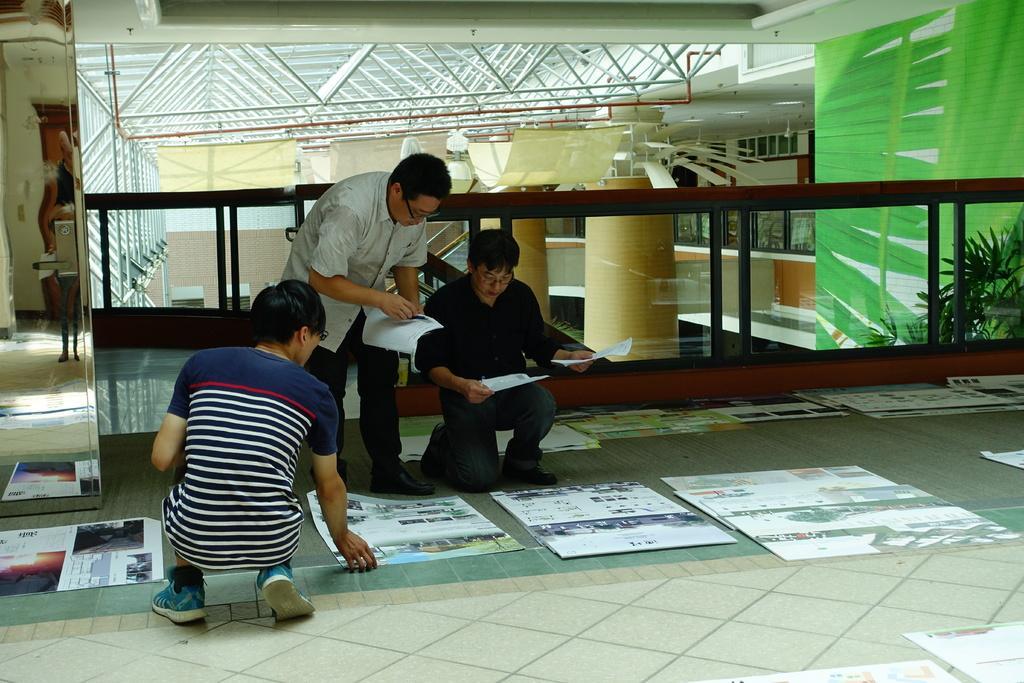Describe this image in one or two sentences. In this picture we can observe three men holding some papers in their hands. There are some charts on the floor. We can observe a railing behind them. There are yellow colored pillars. On the right side we can observe plants. 